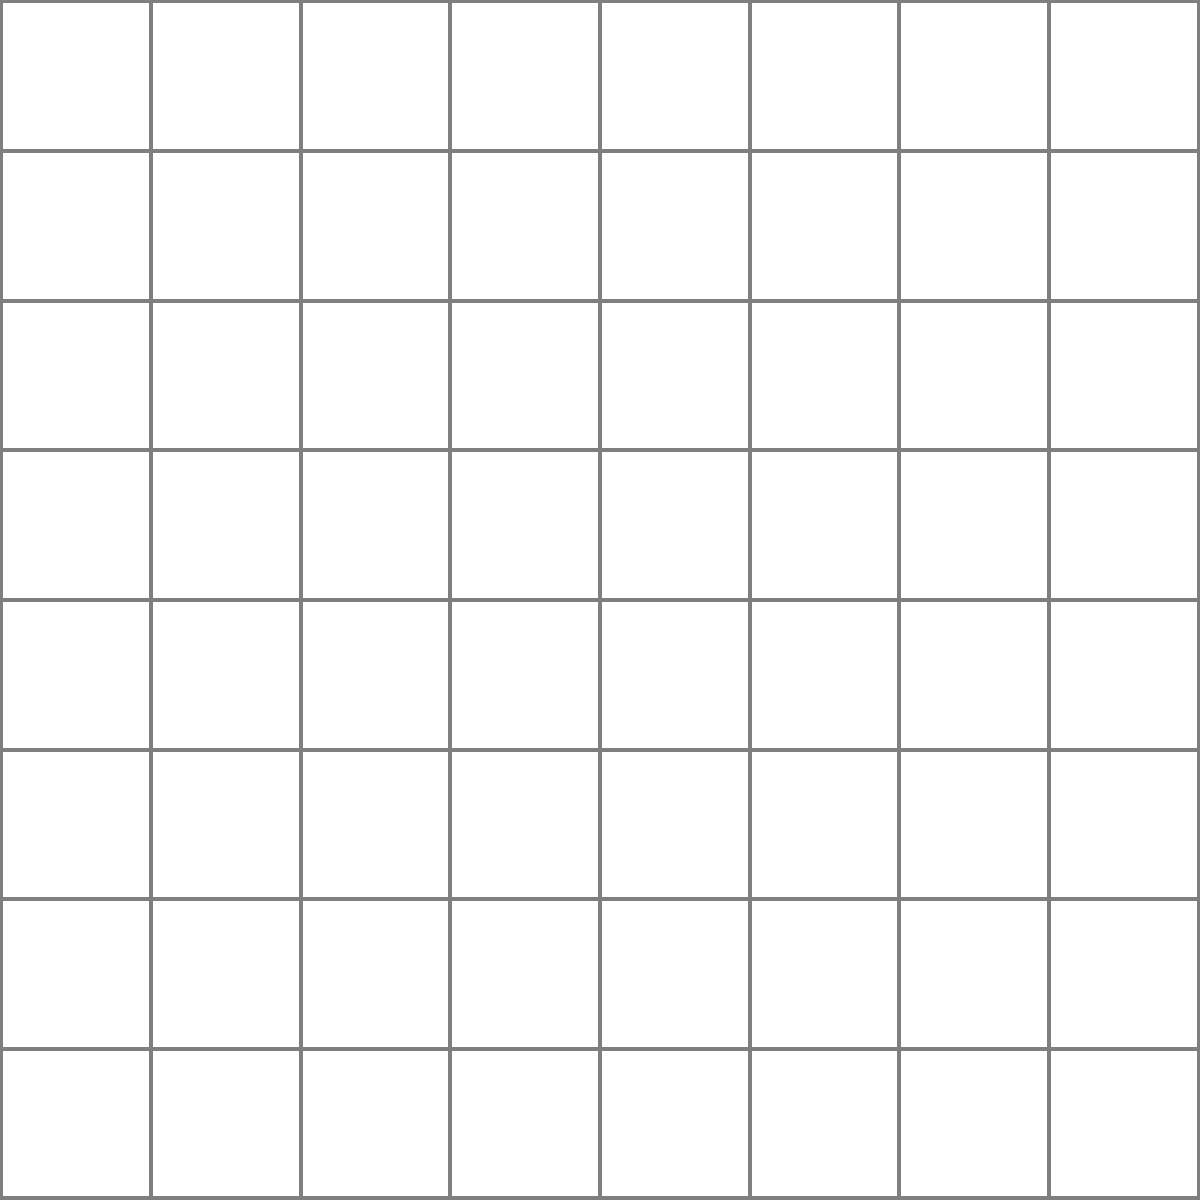In a chess game, a knight moves from square b2 to square d3 as shown in the diagram. Calculate the slope of the line segment representing this move. How might understanding this geometric aspect of chess movements relate to spatial awareness in your sport? To calculate the slope of the knight's move, we'll follow these steps:

1. Identify the coordinates:
   - Start point: b2 corresponds to (2, 1) in the coordinate system
   - End point: d3 corresponds to (4, 2) in the coordinate system

2. Recall the slope formula:
   $$ \text{slope} = \frac{y_2 - y_1}{x_2 - x_1} $$

3. Plug in the values:
   $$ \text{slope} = \frac{2 - 1}{4 - 2} = \frac{1}{2} $$

4. Simplify:
   The slope is already in its simplest form: $\frac{1}{2}$

Understanding the geometric aspects of chess movements, such as calculating slopes, can enhance spatial awareness and pattern recognition. These skills are crucial in many sports, as they help athletes:

1. Anticipate opponent movements
2. Optimize positioning on the field/court
3. Improve decision-making in dynamic situations
4. Enhance overall strategic thinking

By analyzing chess movements mathematically, athletes can develop a more analytical approach to their own sport, potentially leading to improved performance and tactical understanding.
Answer: $\frac{1}{2}$ 